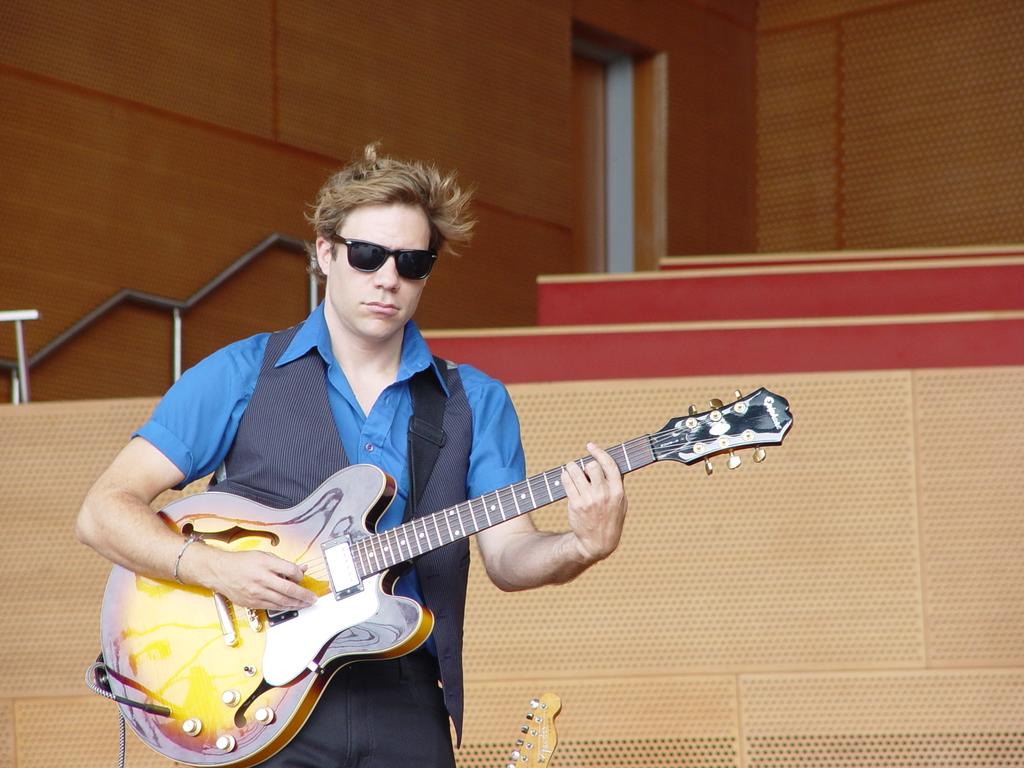What is the person in the image doing? The person is standing in the image and holding a guitar. What object is the person holding in the image? The person is holding a guitar. What can be seen in the background of the image? There is a wooden wall in the background of the image. What type of flesh can be seen on the guitar in the image? There is no flesh visible on the guitar in the image, as it is a musical instrument made of materials like wood or metal. 